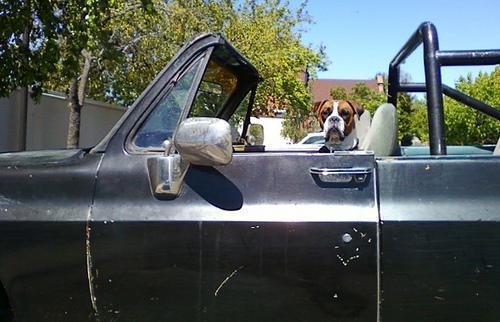How many dogs are there?
Give a very brief answer. 1. How many cars are there?
Give a very brief answer. 1. 